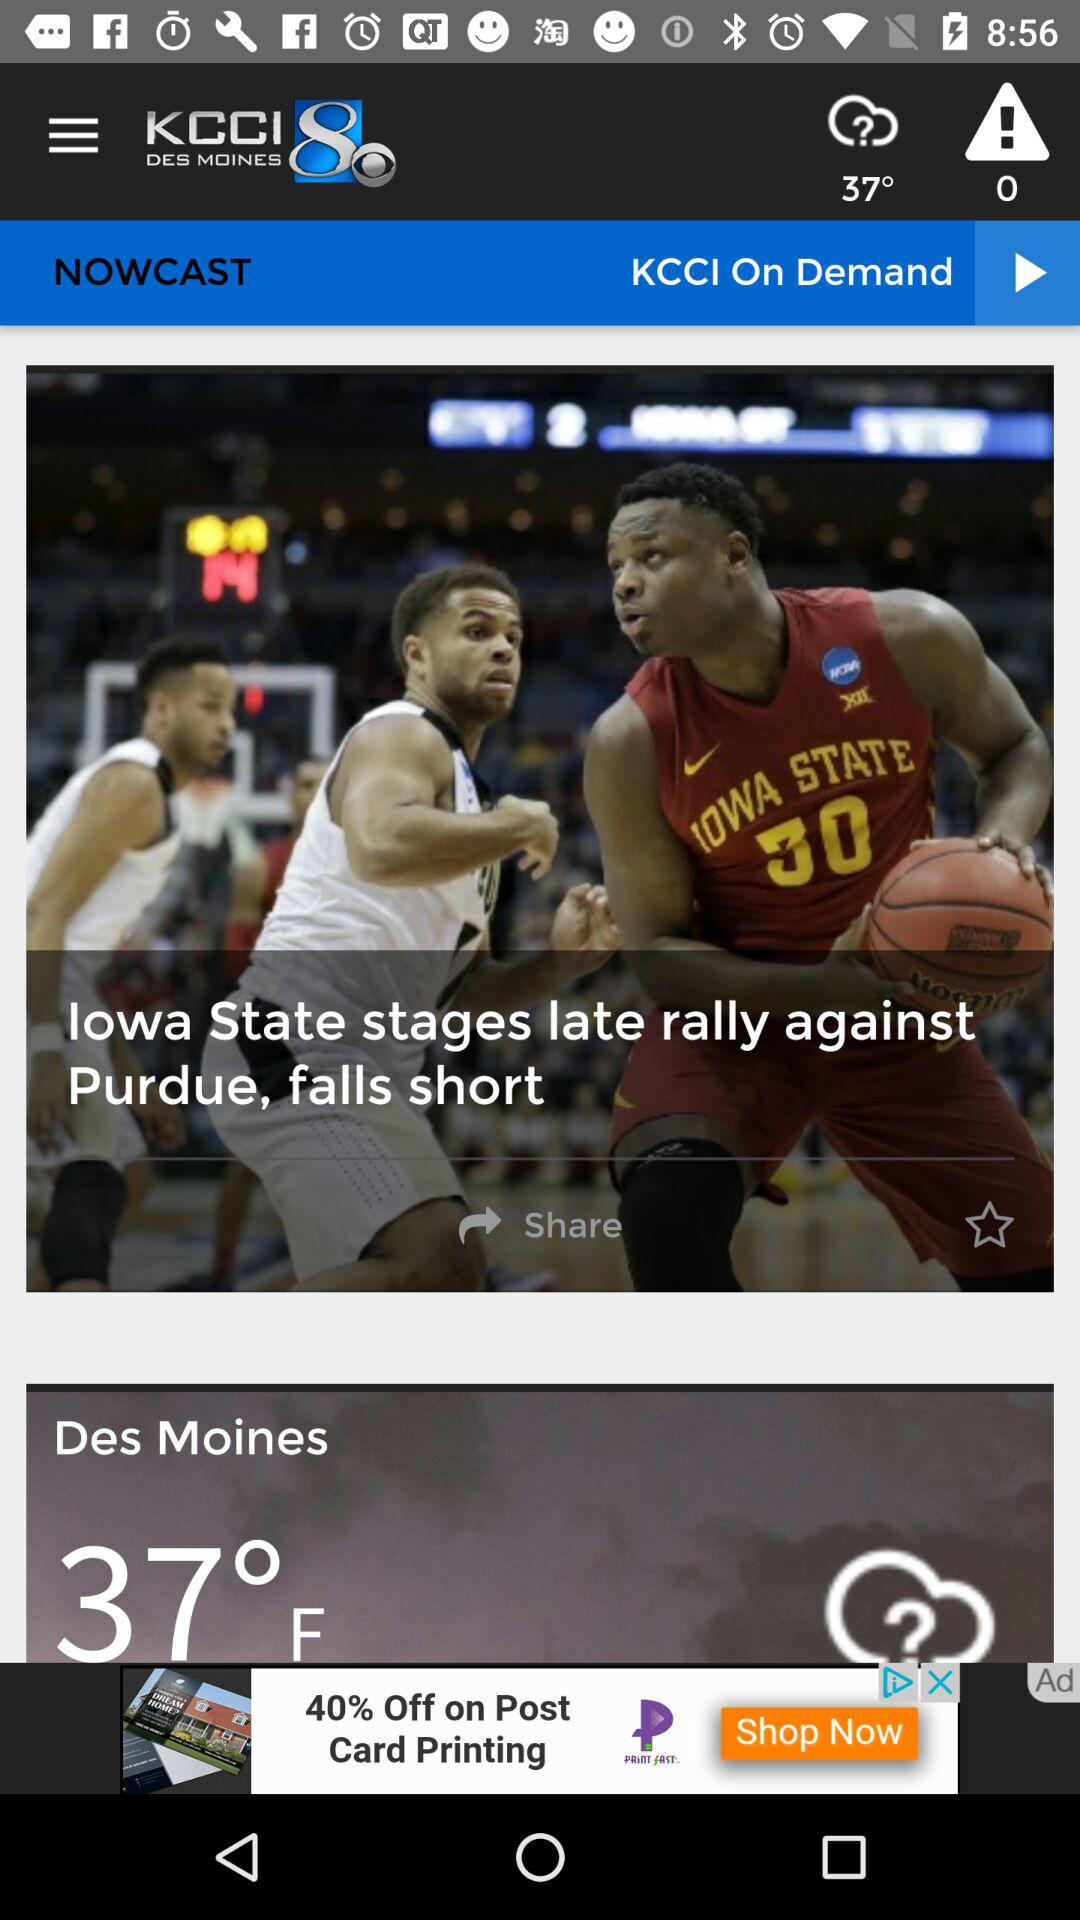What is the temperature in Des Moines? The temperature in Des Moines is 37 °F. 